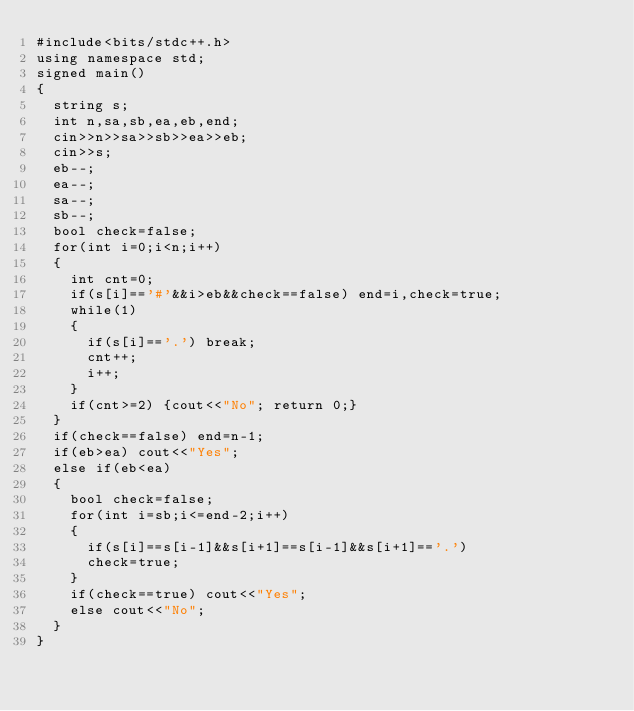<code> <loc_0><loc_0><loc_500><loc_500><_C++_>#include<bits/stdc++.h>
using namespace std;
signed main()
{
	string s;
	int n,sa,sb,ea,eb,end;
	cin>>n>>sa>>sb>>ea>>eb;
	cin>>s;
	eb--;
	ea--;
	sa--;
	sb--;
	bool check=false;
	for(int i=0;i<n;i++)
	{
		int cnt=0;
		if(s[i]=='#'&&i>eb&&check==false) end=i,check=true;
		while(1)
		{
			if(s[i]=='.') break;
			cnt++;
			i++;
		}
		if(cnt>=2) {cout<<"No"; return 0;}
	}
	if(check==false) end=n-1;
	if(eb>ea) cout<<"Yes";
	else if(eb<ea)
	{
		bool check=false;
		for(int i=sb;i<=end-2;i++)
		{
			if(s[i]==s[i-1]&&s[i+1]==s[i-1]&&s[i+1]=='.')
			check=true;
		}	
		if(check==true) cout<<"Yes";
		else cout<<"No";
	}
}</code> 